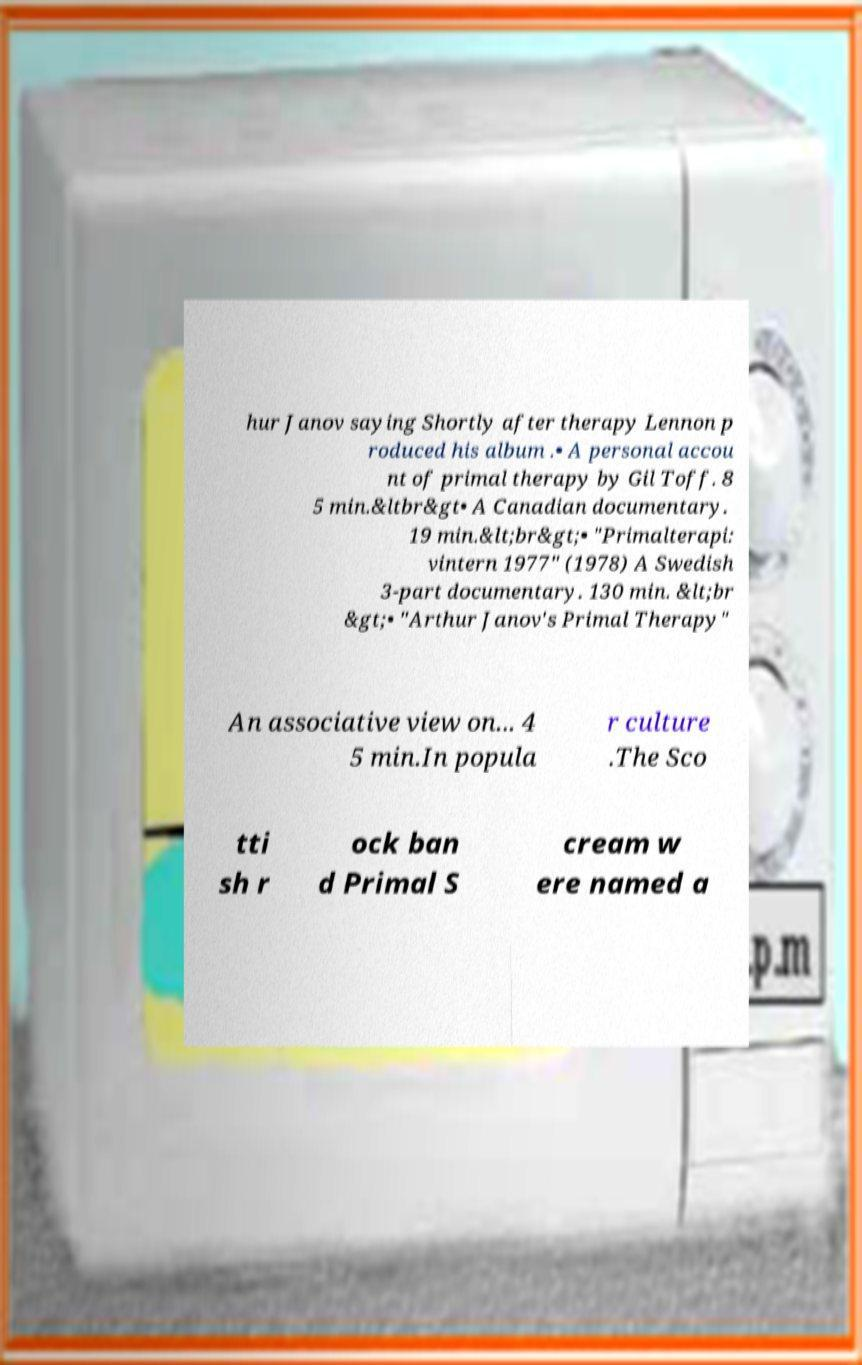Could you assist in decoding the text presented in this image and type it out clearly? hur Janov saying Shortly after therapy Lennon p roduced his album .• A personal accou nt of primal therapy by Gil Toff. 8 5 min.&ltbr&gt• A Canadian documentary. 19 min.&lt;br&gt;• "Primalterapi: vintern 1977" (1978) A Swedish 3-part documentary. 130 min. &lt;br &gt;• "Arthur Janov's Primal Therapy" An associative view on... 4 5 min.In popula r culture .The Sco tti sh r ock ban d Primal S cream w ere named a 